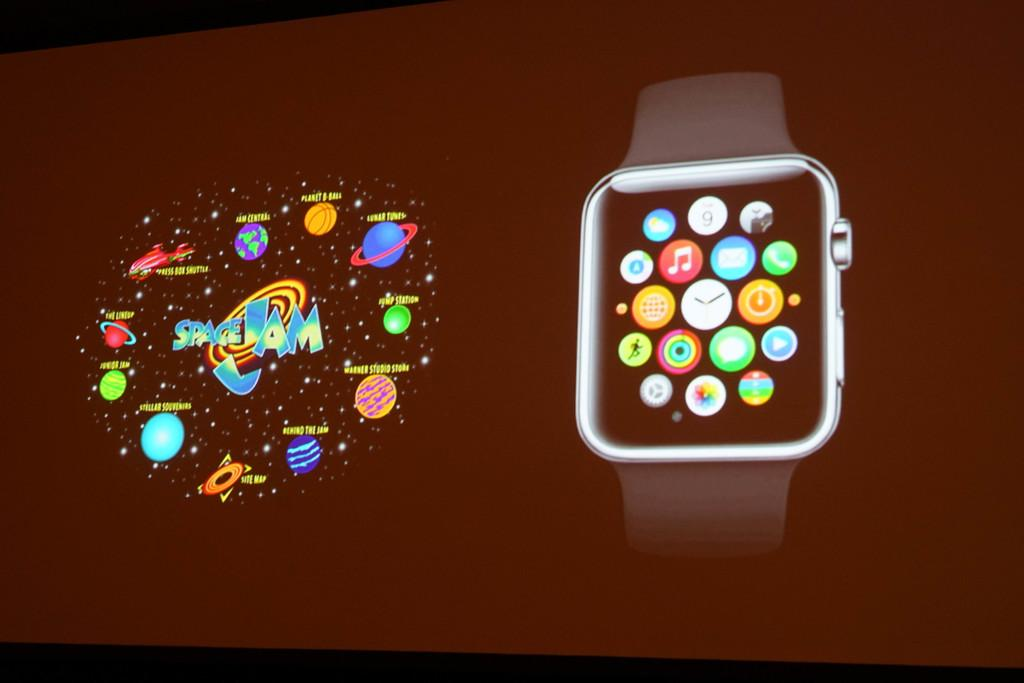<image>
Provide a brief description of the given image. Screen showing different apps with one that says SITE MAP. 